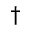<formula> <loc_0><loc_0><loc_500><loc_500>\dagger</formula> 